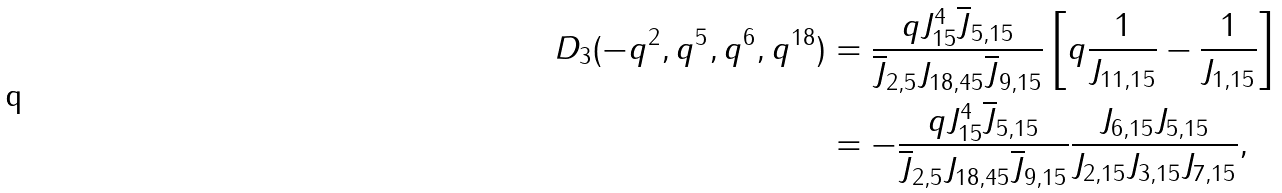<formula> <loc_0><loc_0><loc_500><loc_500>D _ { 3 } ( - q ^ { 2 } , q ^ { 5 } , q ^ { 6 } , q ^ { 1 8 } ) & = \frac { q J _ { 1 5 } ^ { 4 } \overline { J } _ { 5 , 1 5 } } { \overline { J } _ { 2 , 5 } J _ { 1 8 , 4 5 } \overline { J } _ { 9 , 1 5 } } \left [ q \frac { 1 } { J _ { 1 1 , 1 5 } } - \frac { 1 } { J _ { 1 , 1 5 } } \right ] \\ & = - \frac { q J _ { 1 5 } ^ { 4 } \overline { J } _ { 5 , 1 5 } } { \overline { J } _ { 2 , 5 } J _ { 1 8 , 4 5 } \overline { J } _ { 9 , 1 5 } } \frac { J _ { 6 , 1 5 } J _ { 5 , 1 5 } } { J _ { 2 , 1 5 } J _ { 3 , 1 5 } J _ { 7 , 1 5 } } ,</formula> 